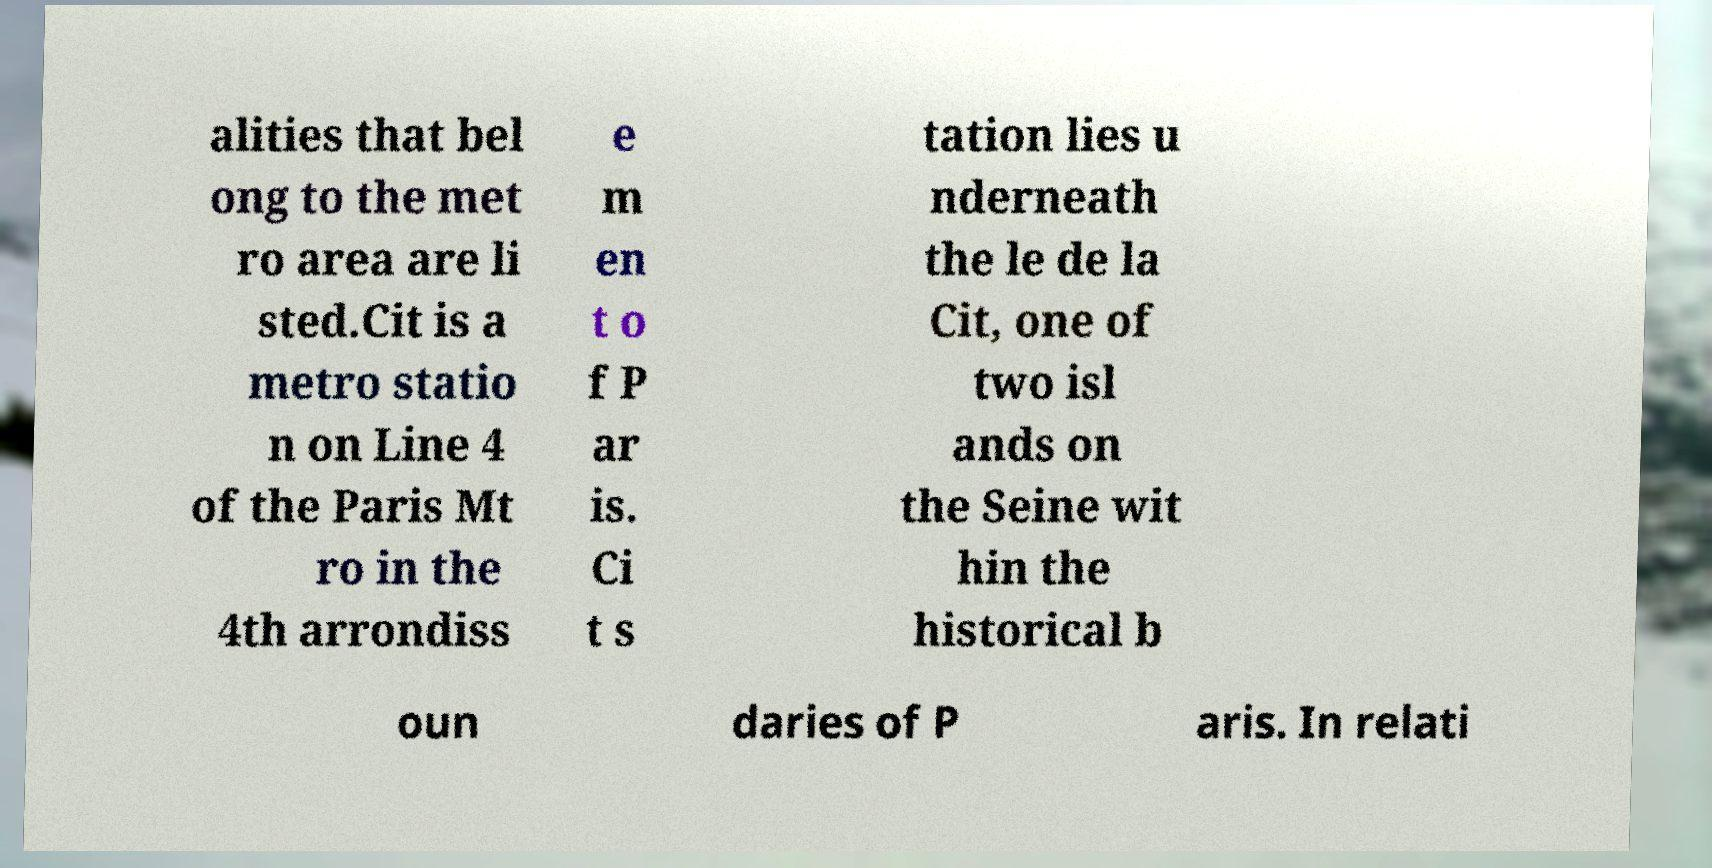There's text embedded in this image that I need extracted. Can you transcribe it verbatim? alities that bel ong to the met ro area are li sted.Cit is a metro statio n on Line 4 of the Paris Mt ro in the 4th arrondiss e m en t o f P ar is. Ci t s tation lies u nderneath the le de la Cit, one of two isl ands on the Seine wit hin the historical b oun daries of P aris. In relati 